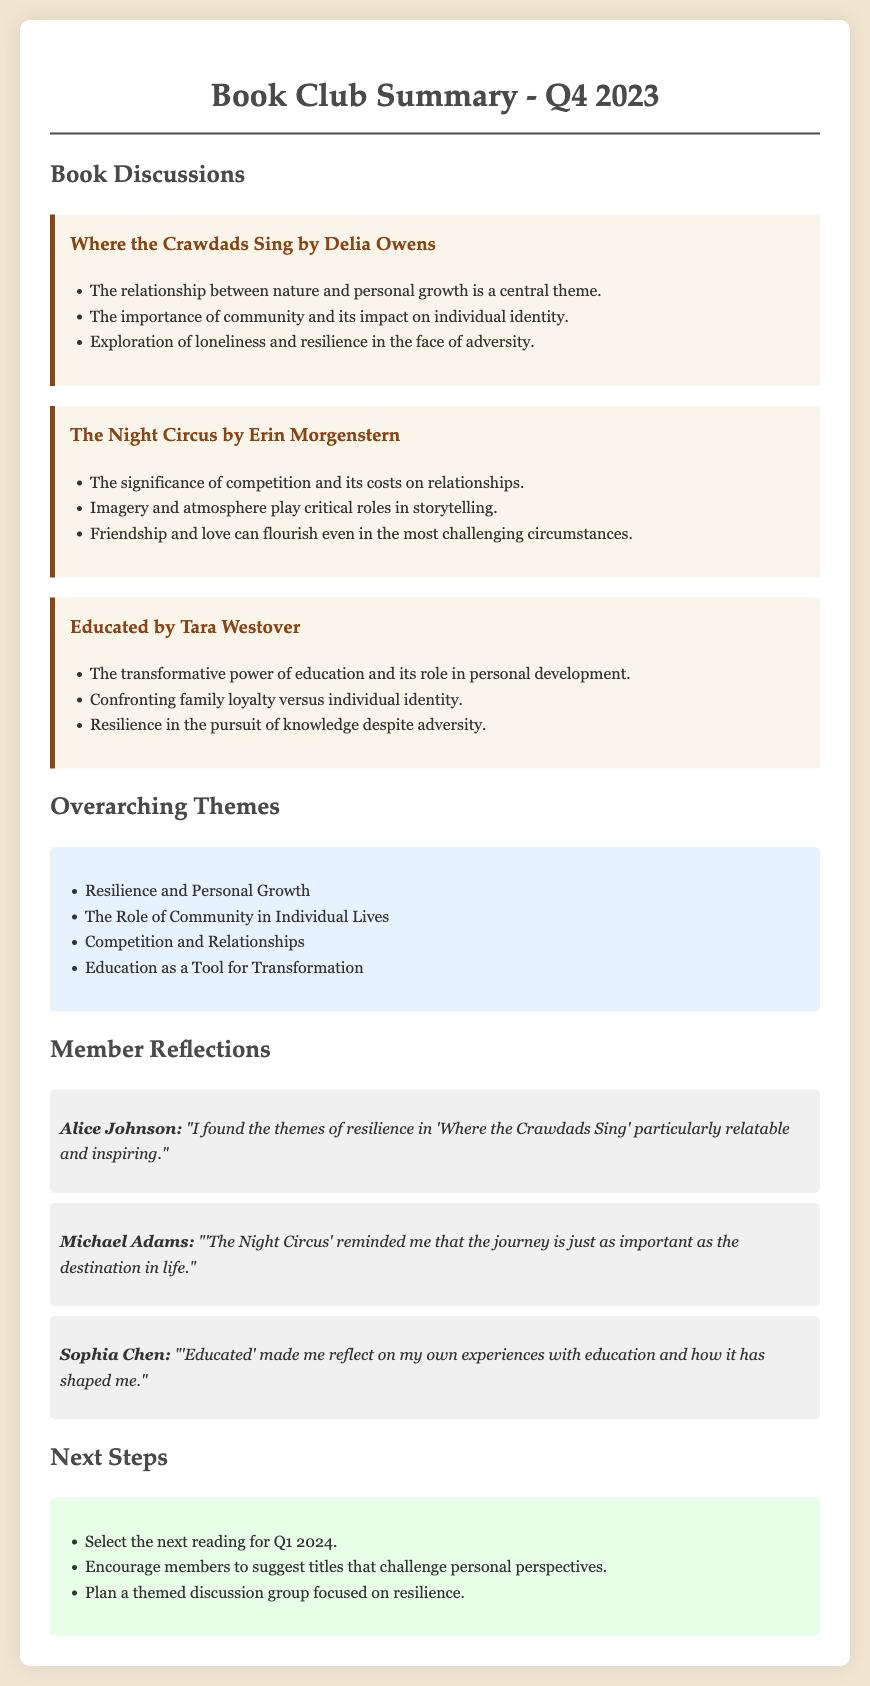What is the title of the first book discussed? The title of the first book can be found under the "Book Discussions" section, specifically listed as the first entry.
Answer: Where the Crawdads Sing by Delia Owens How many themes are listed in the overarching themes section? The number of themes can be counted from the list provided in the "Overarching Themes" section.
Answer: Four Who reflected on the themes in 'Where the Crawdads Sing'? The name of the member reflecting on 'Where the Crawdads Sing' is mentioned in the "Member Reflections" section.
Answer: Alice Johnson What is the overarching theme related to education? The document specifies overarching themes that include the role and impact of education, naming it directly in the themes section.
Answer: Education as a Tool for Transformation What action is suggested for the next steps regarding reading selections? The suggested next steps include specific actions related to future readings, especially about selecting titles.
Answer: Select the next reading for Q1 2024 Which book emphasizes the significance of competition? The specific book discussing the significance of competition is outlined in its respective summary under "Book Discussions."
Answer: The Night Circus by Erin Morgenstern What reflection did Michael Adams provide? The specific reflection by Michael Adams is quoted in the "Member Reflections" section, summarizing his thoughts on 'The Night Circus.'
Answer: "The Night Circus reminded me that the journey is just as important as the destination in life." What kind of discussion group is planned in the next steps? The type of group planned can be identified from the "Next Steps" section, detailing the focus of future discussions.
Answer: Themed discussion group focused on resilience 